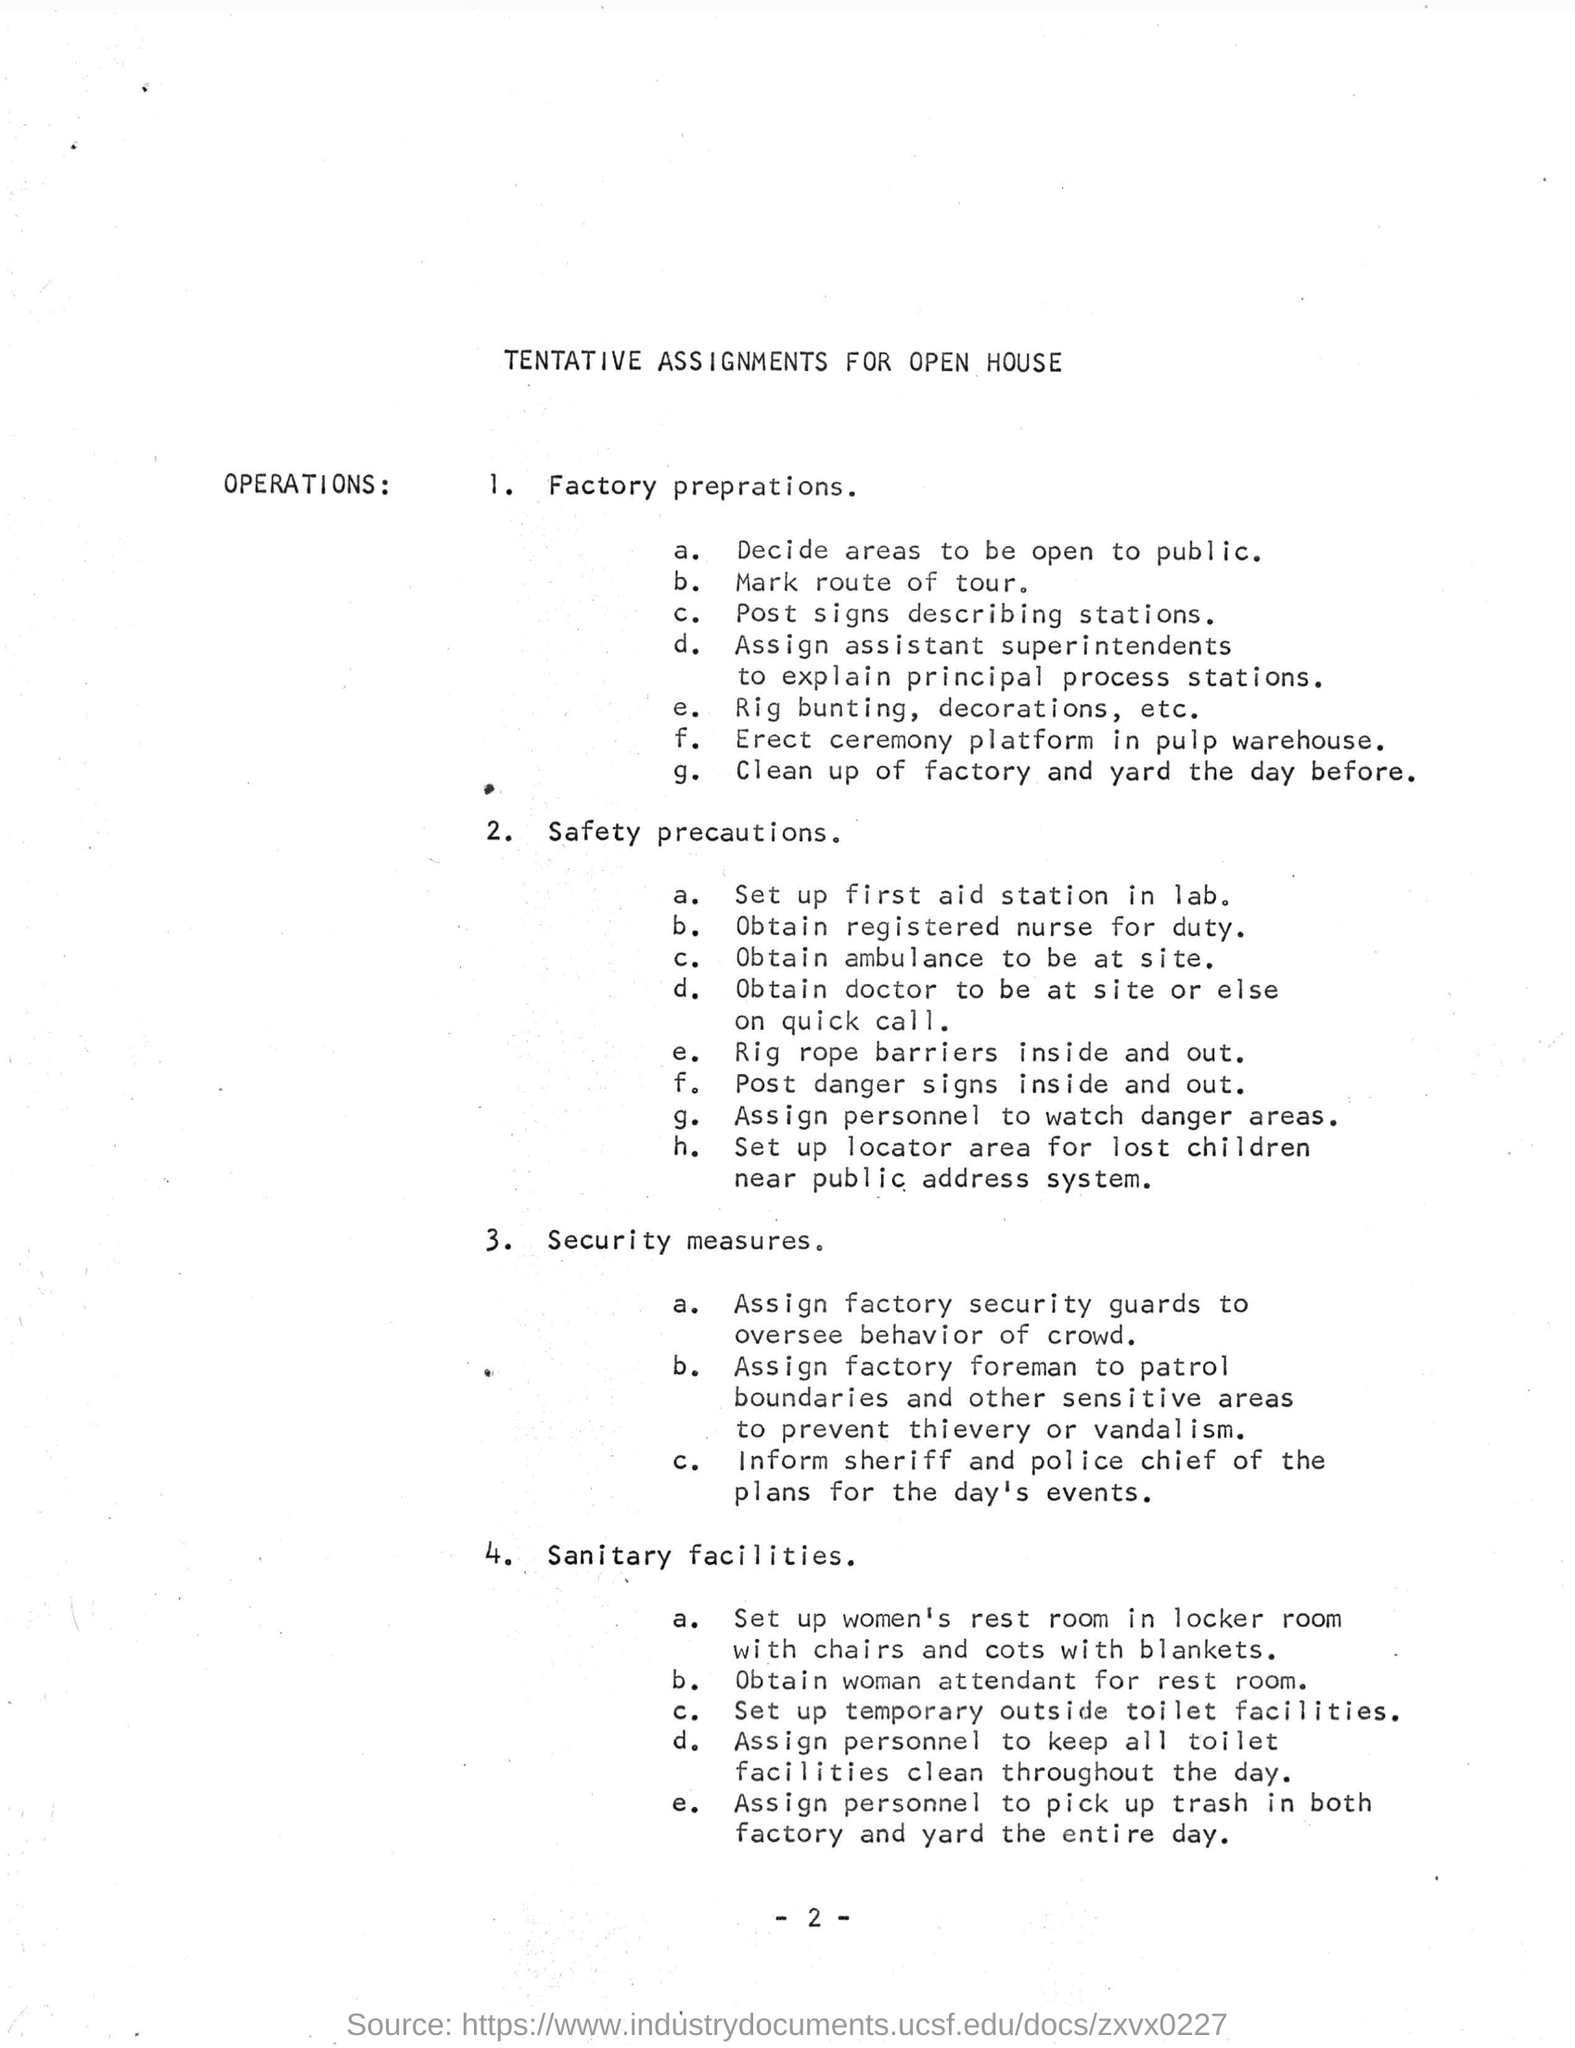Draw attention to some important aspects in this diagram. The location of the first aid station has not been determined yet. The behavior of the crowd is overseen by factory security guards who have been assigned to this responsibility. 